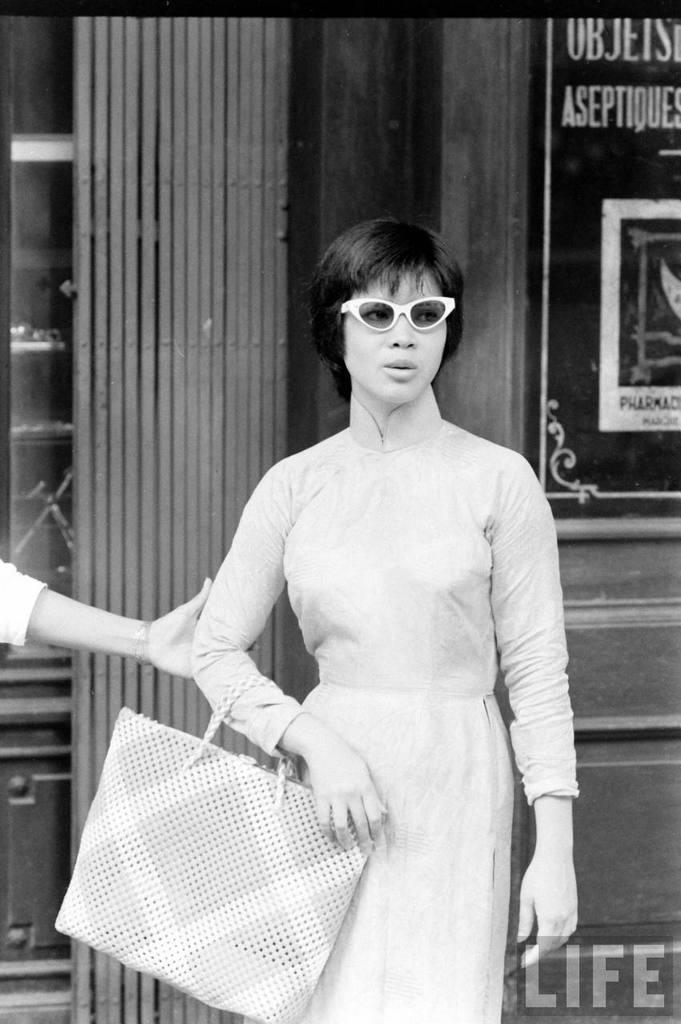What is the lady in the image holding? The lady is holding a handbag and wearing spectacles. Where is the lady standing? The lady is standing on the road. Is there anyone else in the image? Yes, another lady is holding her. What can be seen in the background of the image? There is a grill and a poster in the background. What type of cork can be seen on the plate in the image? There is no cork or plate present in the image. How many tomatoes are on the poster in the background? The poster in the background does not depict any tomatoes. 